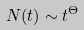Convert formula to latex. <formula><loc_0><loc_0><loc_500><loc_500>N ( t ) \sim t ^ { \Theta }</formula> 